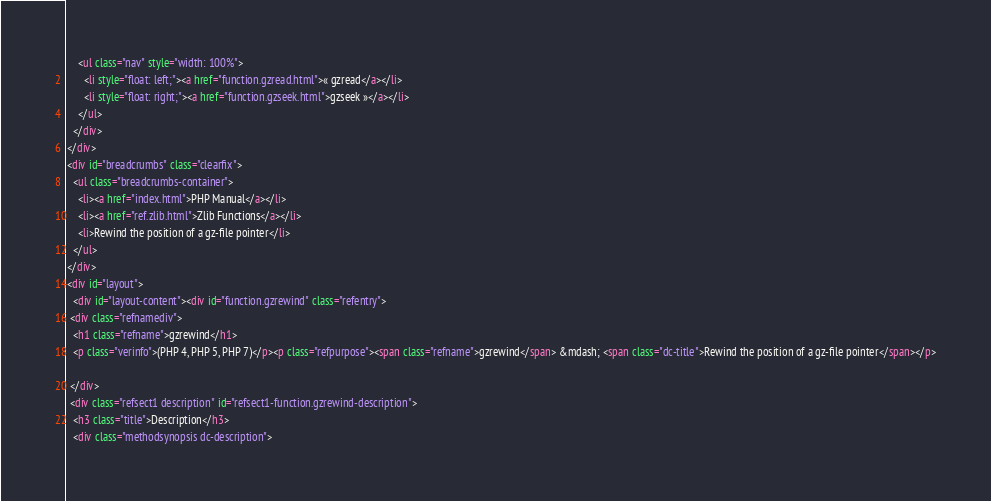<code> <loc_0><loc_0><loc_500><loc_500><_HTML_>    <ul class="nav" style="width: 100%">
      <li style="float: left;"><a href="function.gzread.html">« gzread</a></li>
      <li style="float: right;"><a href="function.gzseek.html">gzseek »</a></li>
    </ul>
  </div>
</div>
<div id="breadcrumbs" class="clearfix">
  <ul class="breadcrumbs-container">
    <li><a href="index.html">PHP Manual</a></li>
    <li><a href="ref.zlib.html">Zlib Functions</a></li>
    <li>Rewind the position of a gz-file pointer</li>
  </ul>
</div>
<div id="layout">
  <div id="layout-content"><div id="function.gzrewind" class="refentry">
 <div class="refnamediv">
  <h1 class="refname">gzrewind</h1>
  <p class="verinfo">(PHP 4, PHP 5, PHP 7)</p><p class="refpurpose"><span class="refname">gzrewind</span> &mdash; <span class="dc-title">Rewind the position of a gz-file pointer</span></p>

 </div>
 <div class="refsect1 description" id="refsect1-function.gzrewind-description">
  <h3 class="title">Description</h3>
  <div class="methodsynopsis dc-description"></code> 